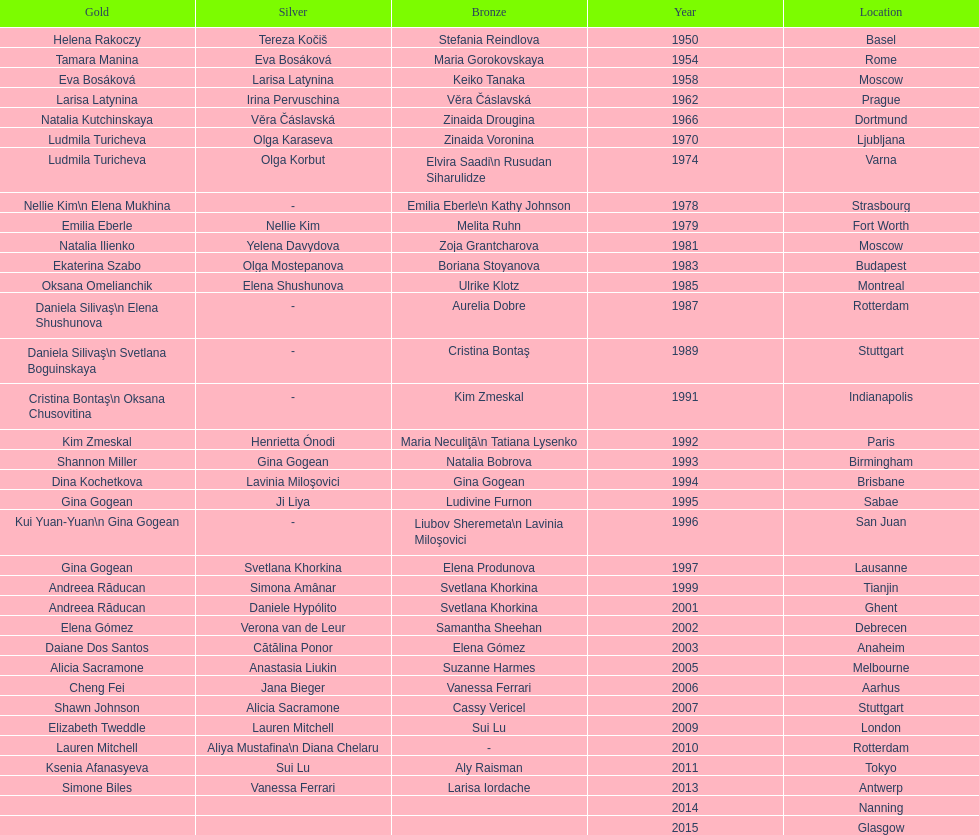In 1992 and 1993, which two american opponents successively claimed the gold medals for floor exercise at the artistic gymnastics world championships? Kim Zmeskal, Shannon Miller. 